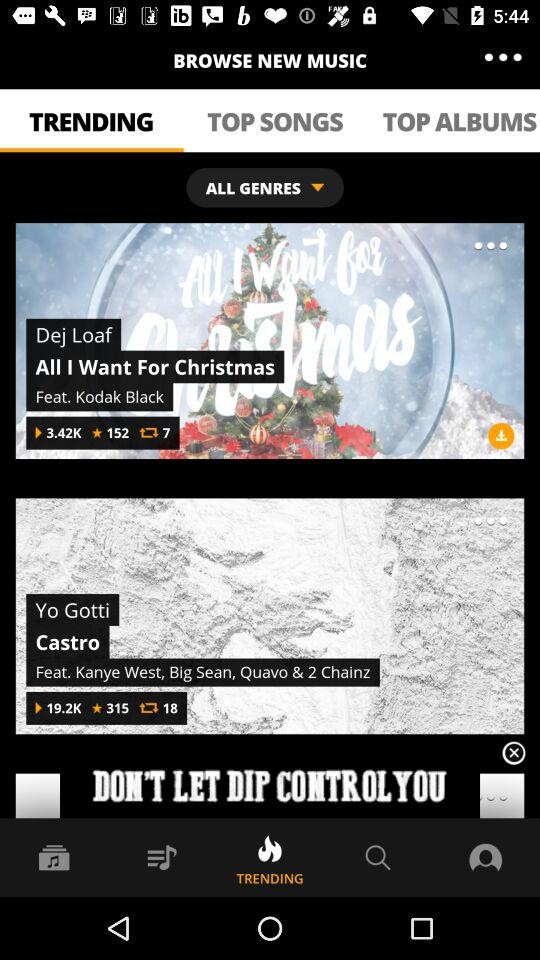Who is the artist for the Castro? The artist for the Castro is Yo Gotti. 